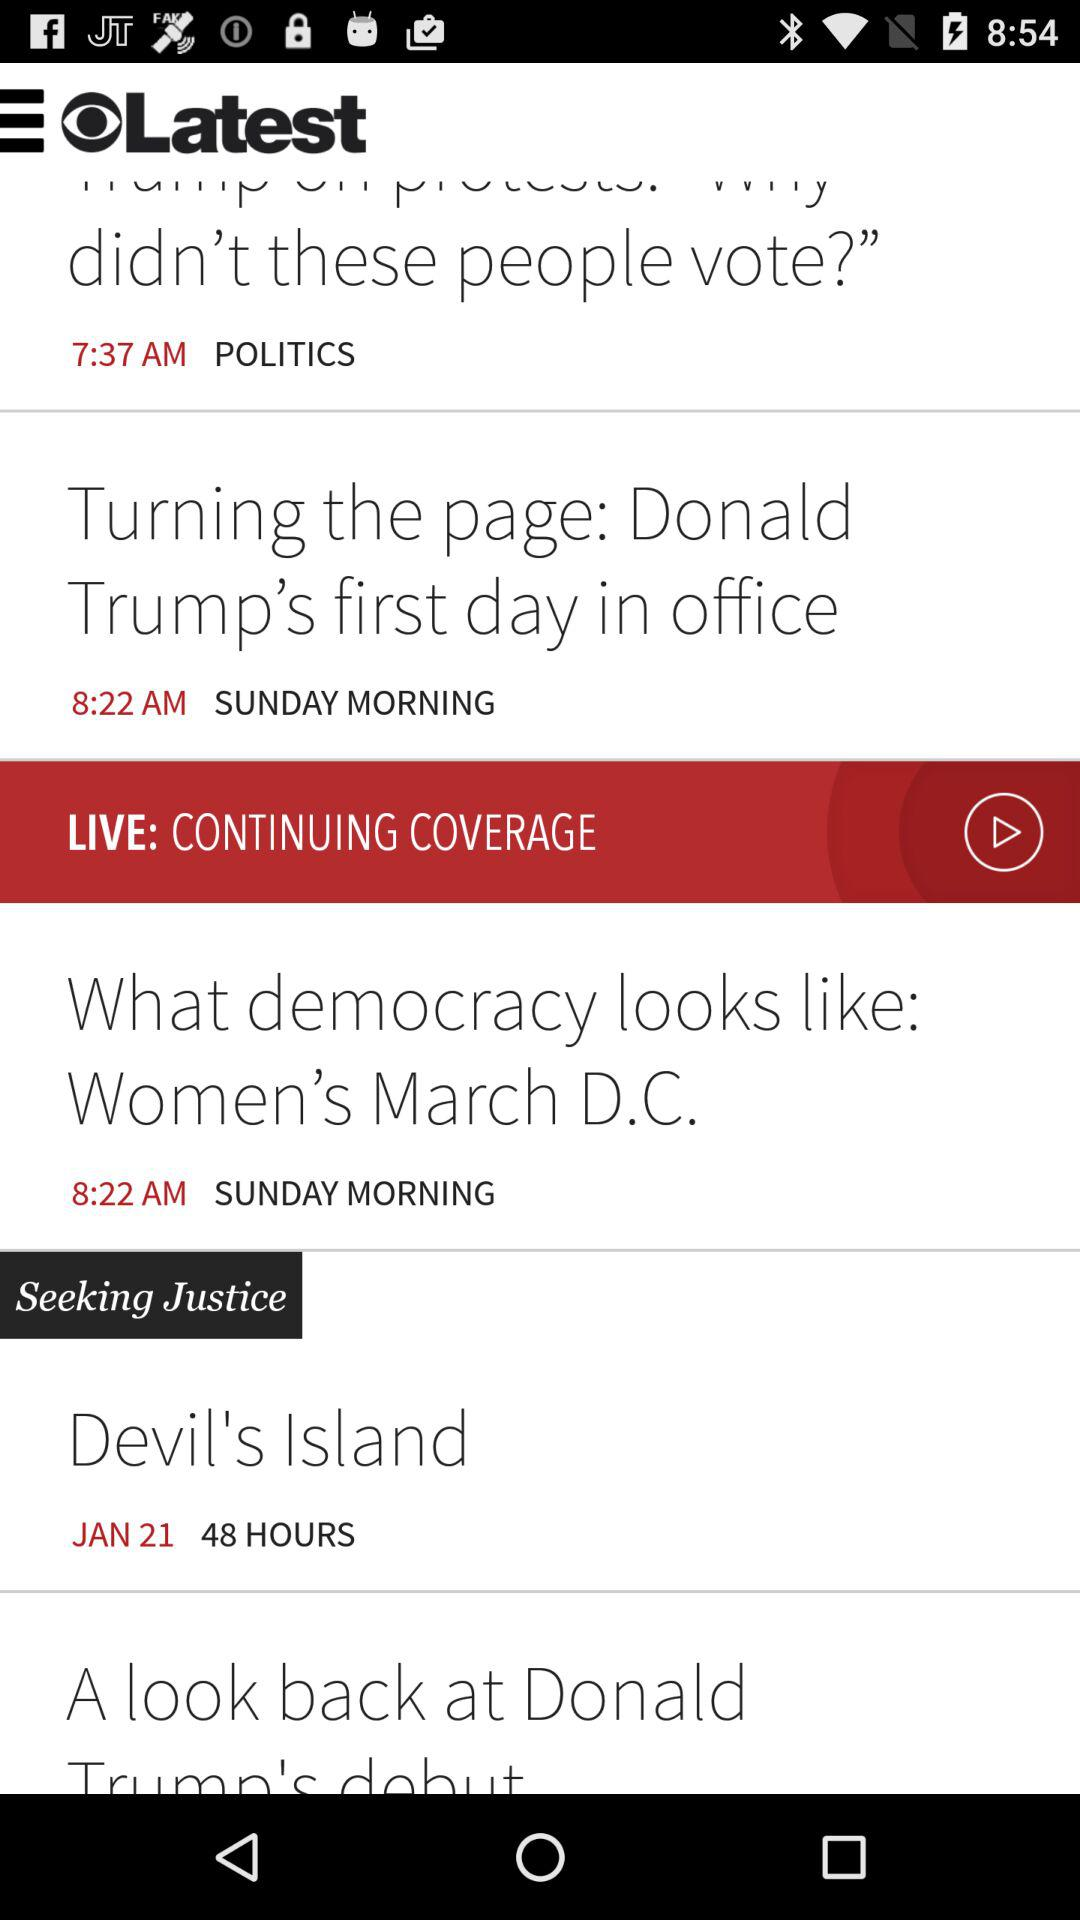When was "Devil's Island" published? "Devil's Island" was published on January 21. 